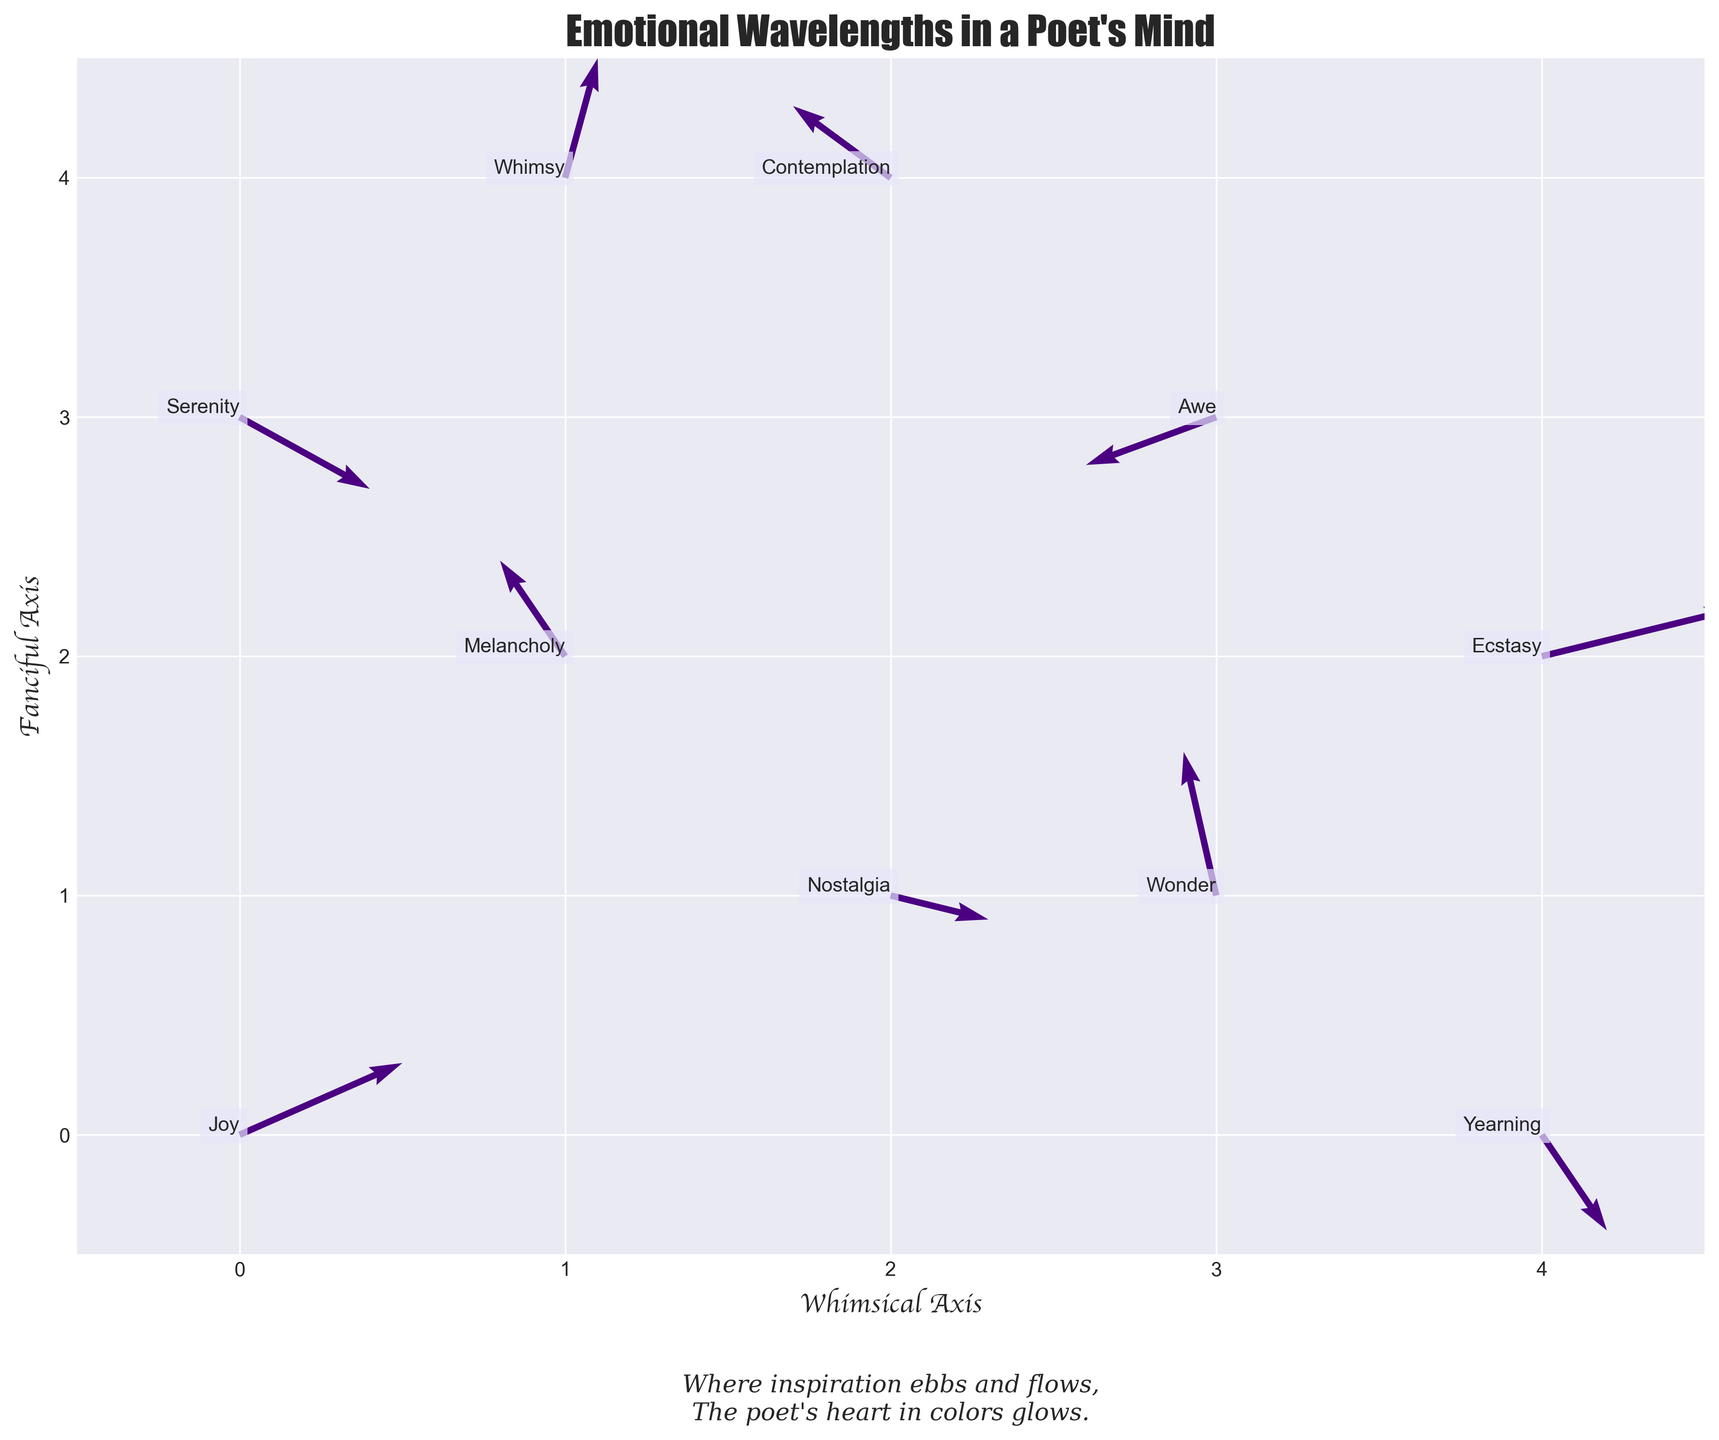What is the title of the plot? The title of the plot is usually displayed at the top of the figure. By looking at the top of the figure, we can see the title "Emotional Wavelengths in a Poet's Mind."
Answer: Emotional Wavelengths in a Poet's Mind What are the labels for the X and Y axes? Axes labels are typically positioned close to their respective axes. In this case, the left and bottom sides of the plot show the labels "Fanciful Axis" and "Whimsical Axis."
Answer: Whimsical Axis, Fanciful Axis How many arrows (data points) are shown in the quiver plot? Count each arrow represented in the plot. There are arrows starting from the points (0,0), (1,2), (2,1), (3,3), (1,4), (4,2), (2,4), (4,0), (3,1), and (0,3), which total to 10 arrows.
Answer: 10 Which emotion directs the arrow of highest magnitude and in which direction? Calculate the magnitude of each arrow using the formula √(U² + V²) and compare them. The arrow at (4,2) with components (0.6, 0.2) has the highest magnitude √(0.6² + 0.2²) = √0.4 ≈ 0.63 and it represents Ecstasy.
Answer: Ecstasy, (0.6, 0.2) How many arrows point generally upwards? An arrow points upwards if its V component is positive. Arrows from (0,0), (1,2), (1,4), (4,2), (2,4), (3,1) fall in this category. Count these to get the answer: 6 arrows.
Answer: 6 Which emotion lies at the intersection of the first and fourth cells along the X and Y axes, and what is the direction of its movement? Locate the points (4,0) and (0,3), with the latter representing Serenity and movement (0.4, -0.3). The movement direction can be considered downwards and slightly to the right.
Answer: Serenity, (0.4, -0.3) Which emotional label represents an arrow starting at (2,1) and which direction does it face? The point (2,1) corresponds to the emotion Nostalgia. The arrow directs with components (0.3, -0.1), indicating a movement to the right and slightly downwards.
Answer: Nostalgia, (0.3, -0.1) Calculate the average U and V of the arrows representing Melancholy and Joy. Melancholy at (1,2) has (U,V) = (-0.2, 0.4) and Joy at (0,0) has (U,V) = (0.5, 0.3). The average U component = (0.5 - 0.2)/2 = 0.15. The average V component = (0.3 + 0.4)/2 = 0.35.
Answer: U=0.15, V=0.35 